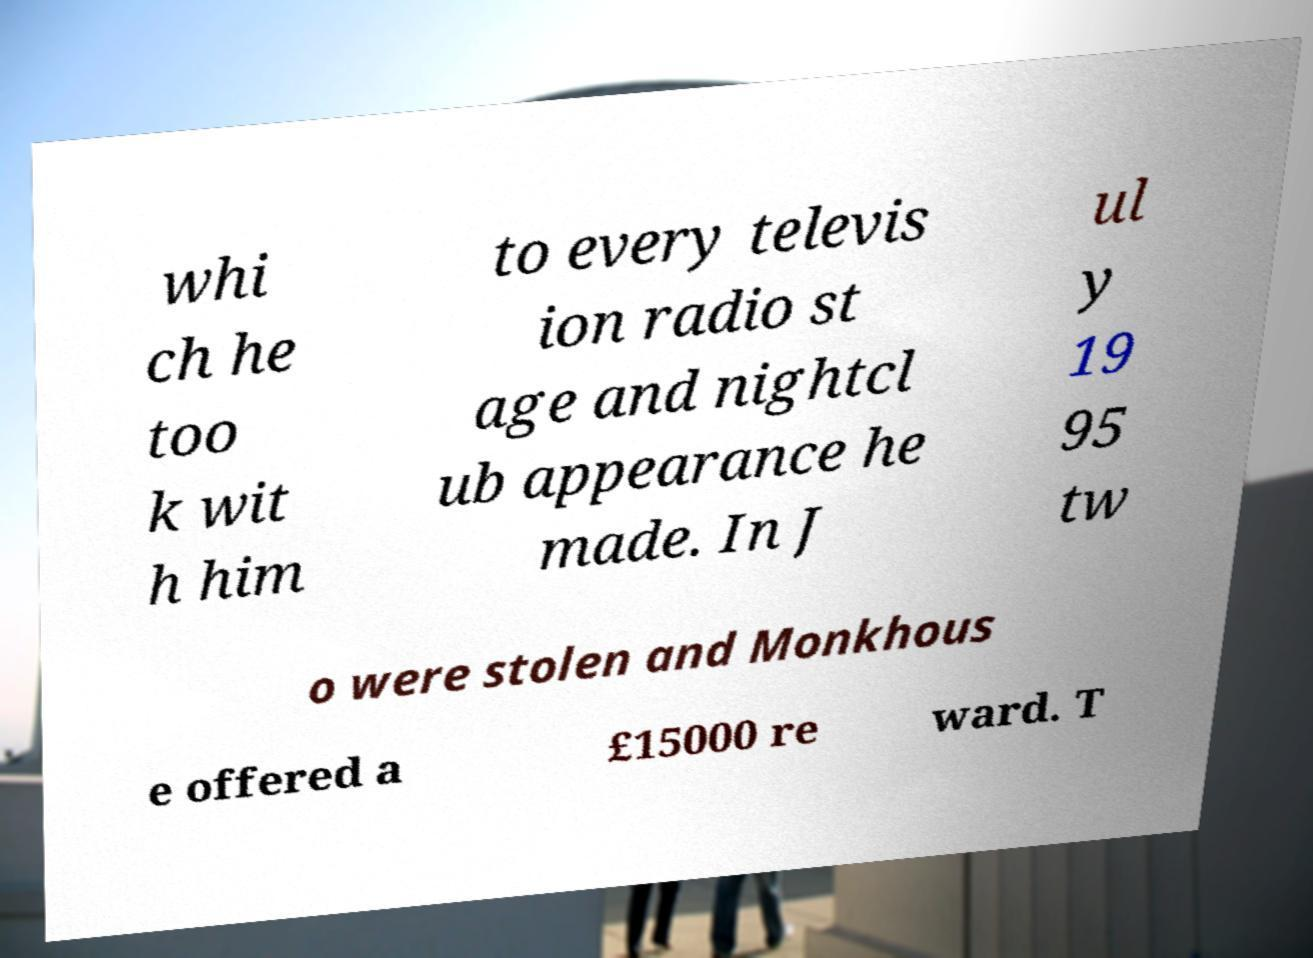There's text embedded in this image that I need extracted. Can you transcribe it verbatim? whi ch he too k wit h him to every televis ion radio st age and nightcl ub appearance he made. In J ul y 19 95 tw o were stolen and Monkhous e offered a £15000 re ward. T 